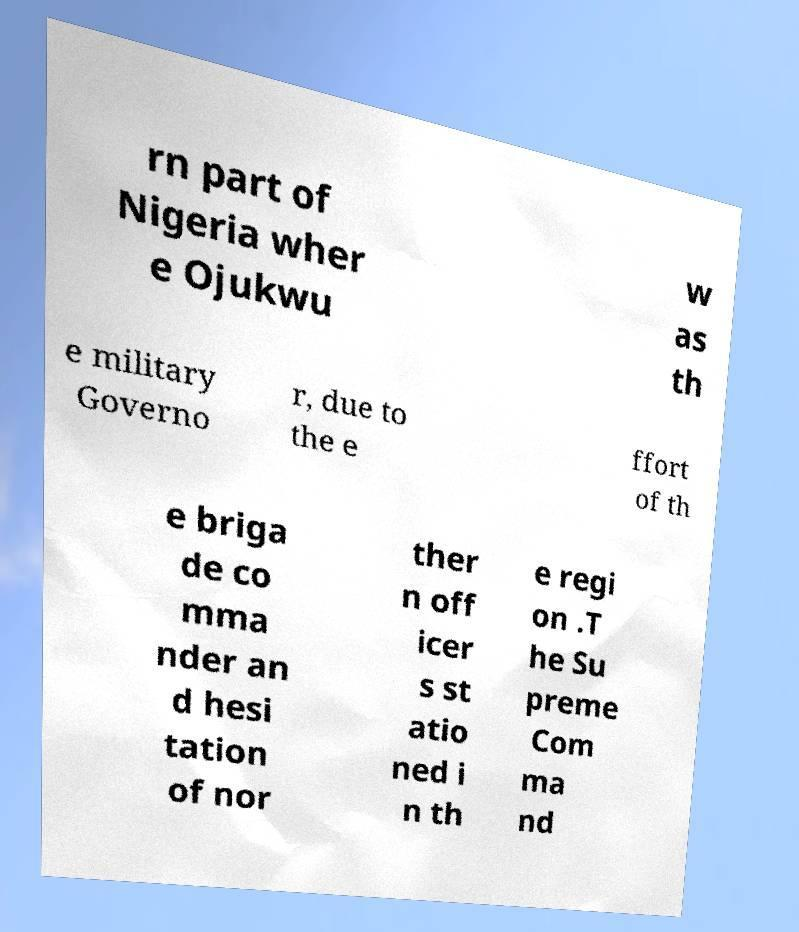What messages or text are displayed in this image? I need them in a readable, typed format. rn part of Nigeria wher e Ojukwu w as th e military Governo r, due to the e ffort of th e briga de co mma nder an d hesi tation of nor ther n off icer s st atio ned i n th e regi on .T he Su preme Com ma nd 